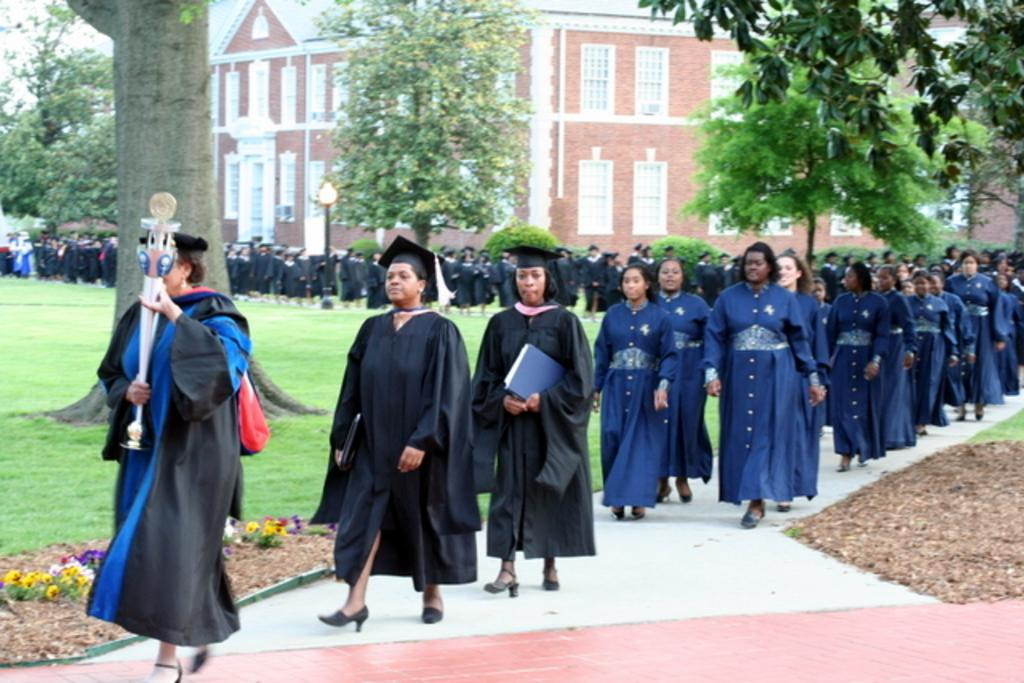What is happening with the group of people in the image? The group of people is on the ground in the image. What type of vegetation can be seen in the image? There are flowers visible in the image. What can be seen in the distance in the image? There is a building and trees in the background of the image. How does the wrist of the baby in the image affect the friction between the flowers and the ground? There is no baby present in the image, and therefore no wrist to affect the friction between the flowers and the ground. 